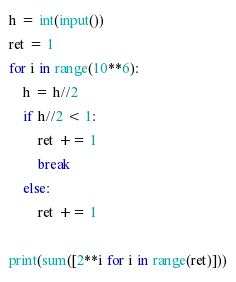<code> <loc_0><loc_0><loc_500><loc_500><_Python_>h = int(input())
ret = 1
for i in range(10**6):
    h = h//2
    if h//2 < 1:
        ret += 1
        break
    else:
        ret += 1

print(sum([2**i for i in range(ret)]))</code> 